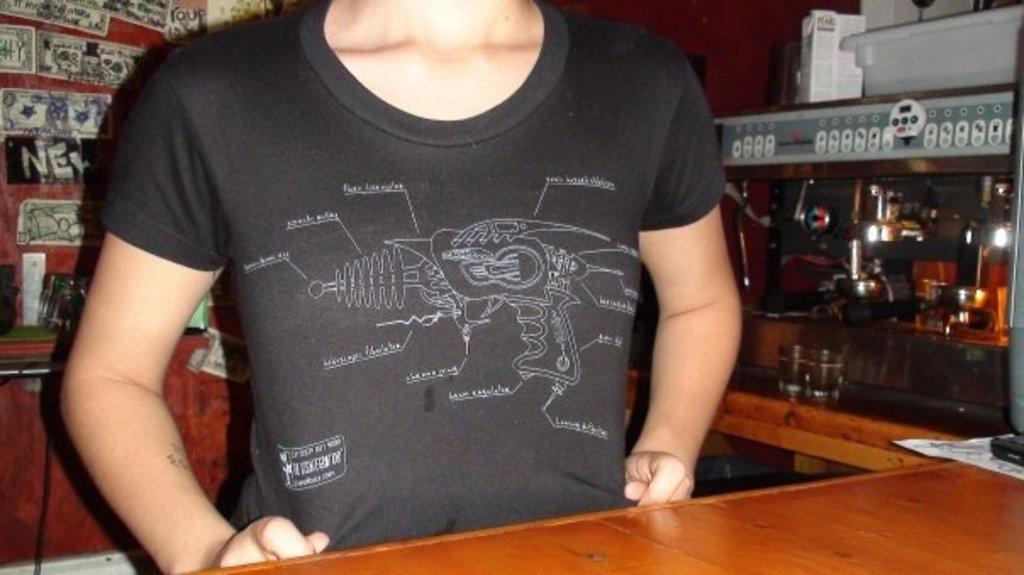What can be seen in the image? There is a person in the image, and they are wearing clothes. What type of surface is present in the image? There is a wooden surface in the image. What objects can be seen on the wooden surface? There are glasses and a cable wire visible on the wooden surface. Can you describe the person's attire in the image? The person is wearing clothes, but the specific type of clothing is not mentioned in the facts. How many combs are visible in the image? There is no mention of combs in the facts, so we cannot determine the number of combs in the image. Is there a nest in the image? There is no mention of a nest in the facts, so we cannot determine if there is a nest in the image. 